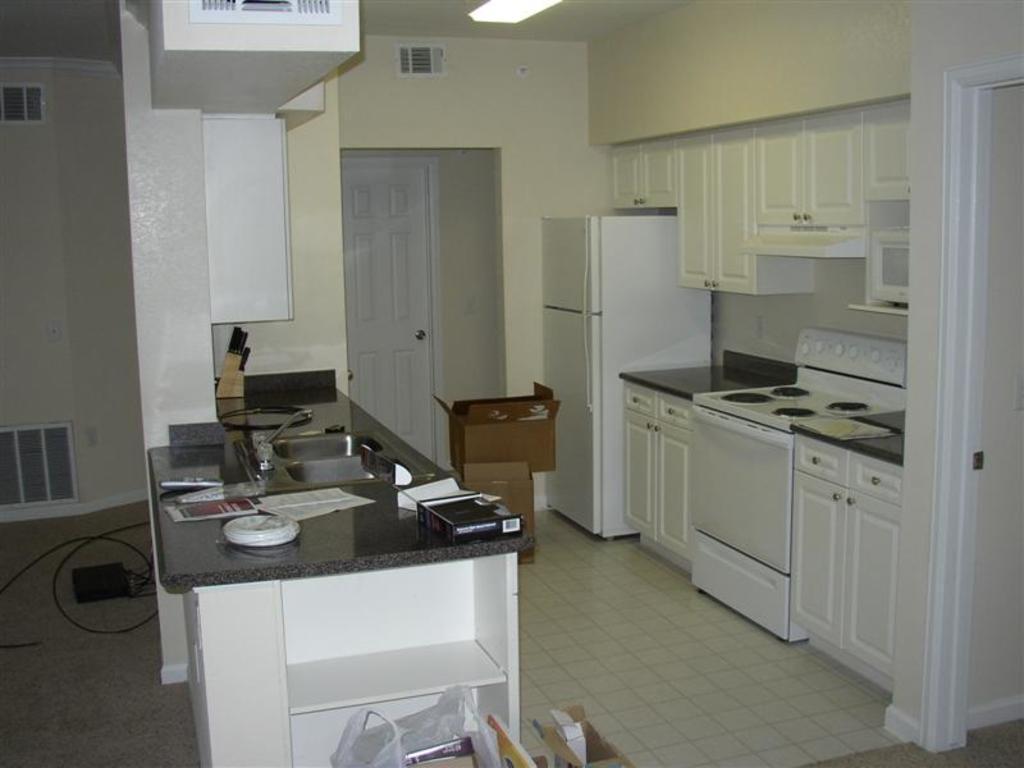How would you summarize this image in a sentence or two? The picture is taken inside the kitchen. In this image there is kitchen platform in the middle in which there is a sink and there are few papers and remotes around it. On the right side there is a stove at the bottom. At the top there are cupboards. Beside the stove there is a fridge. On the floor there are cardboard boxes. In the background there is a door. At the top there is the light. On the left side there are wires at the bottom. 